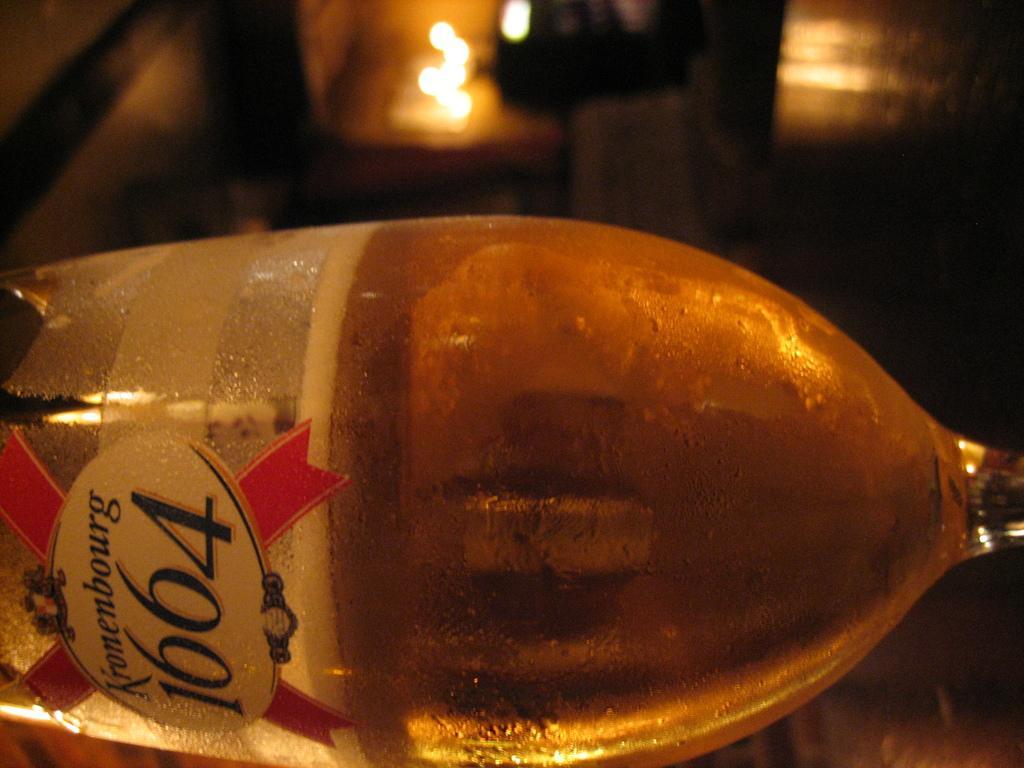Describe this image in one or two sentences. In this image there is a zoom in picture of a bottle as we can see at bottom of this image. 